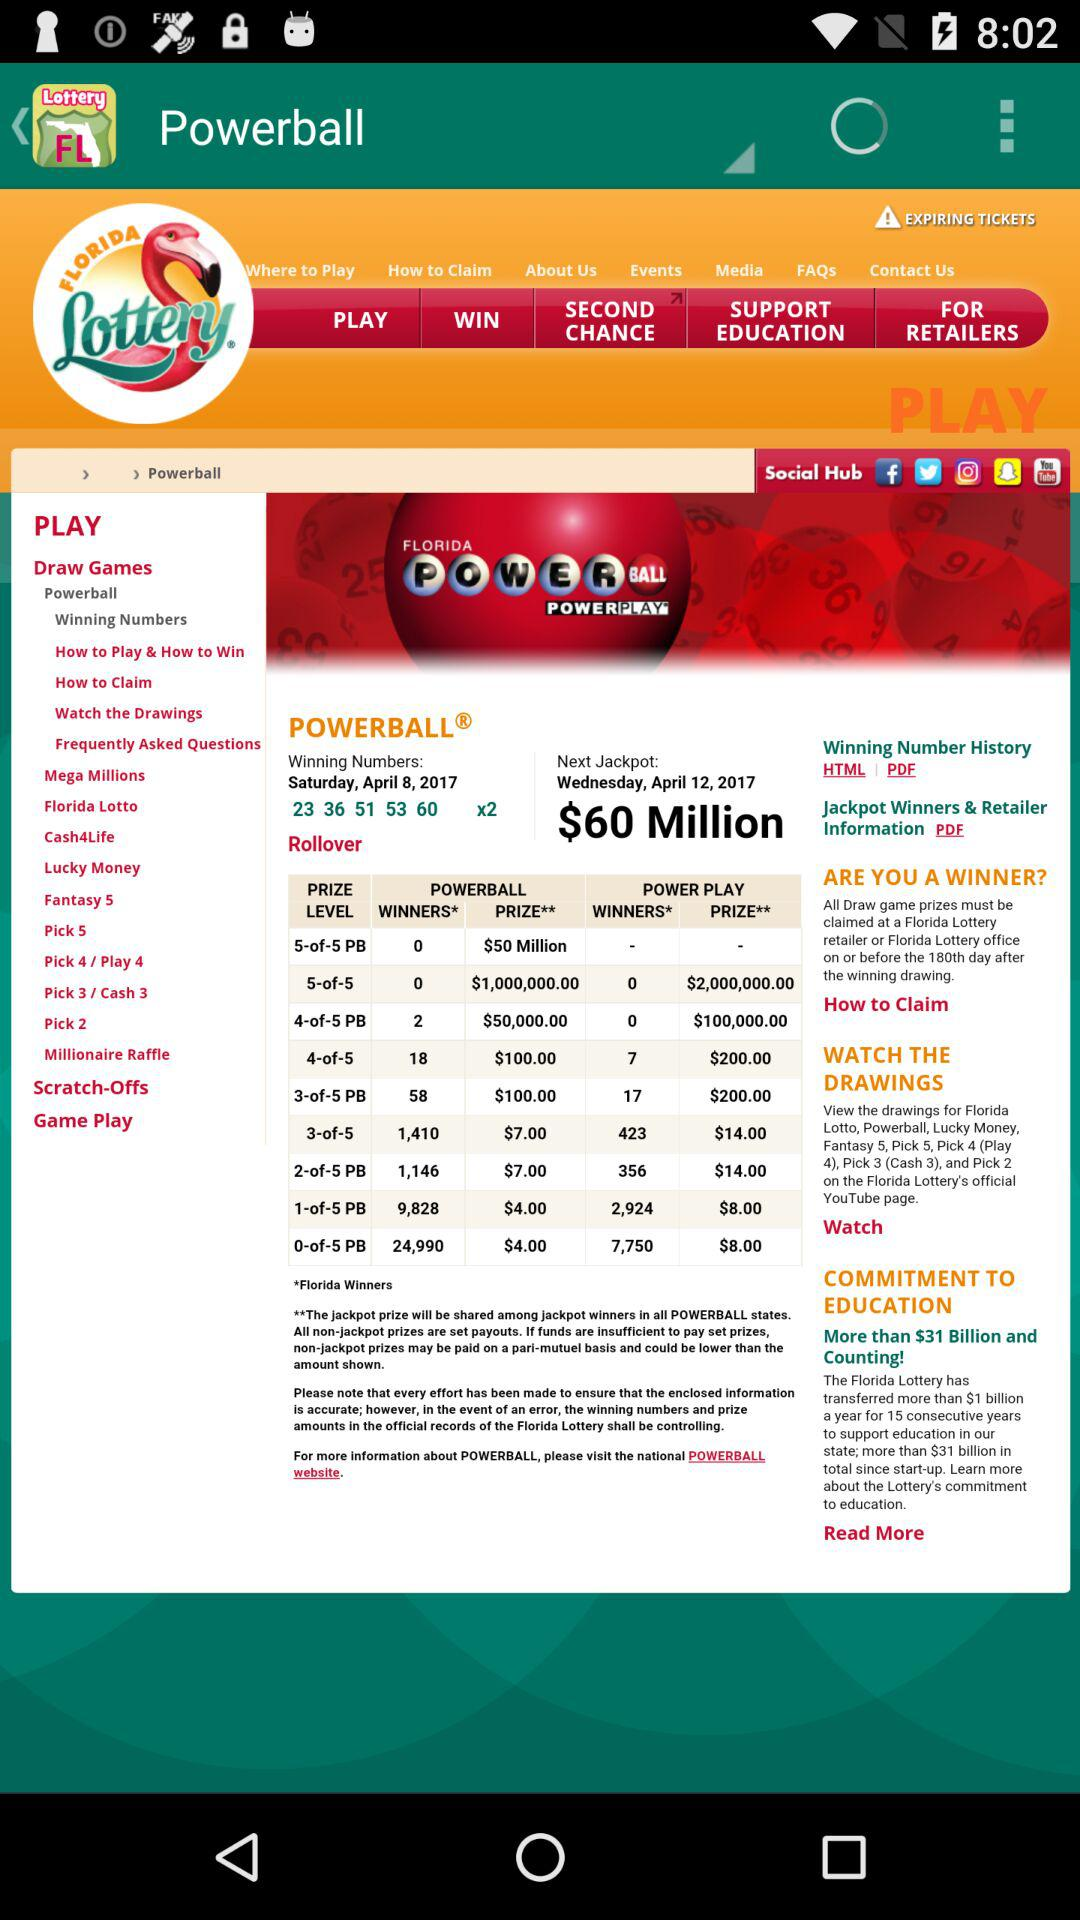What are the winning numbers on April 8, 2017? The winning numbers are 23, 36, 51, 53 and 60. 